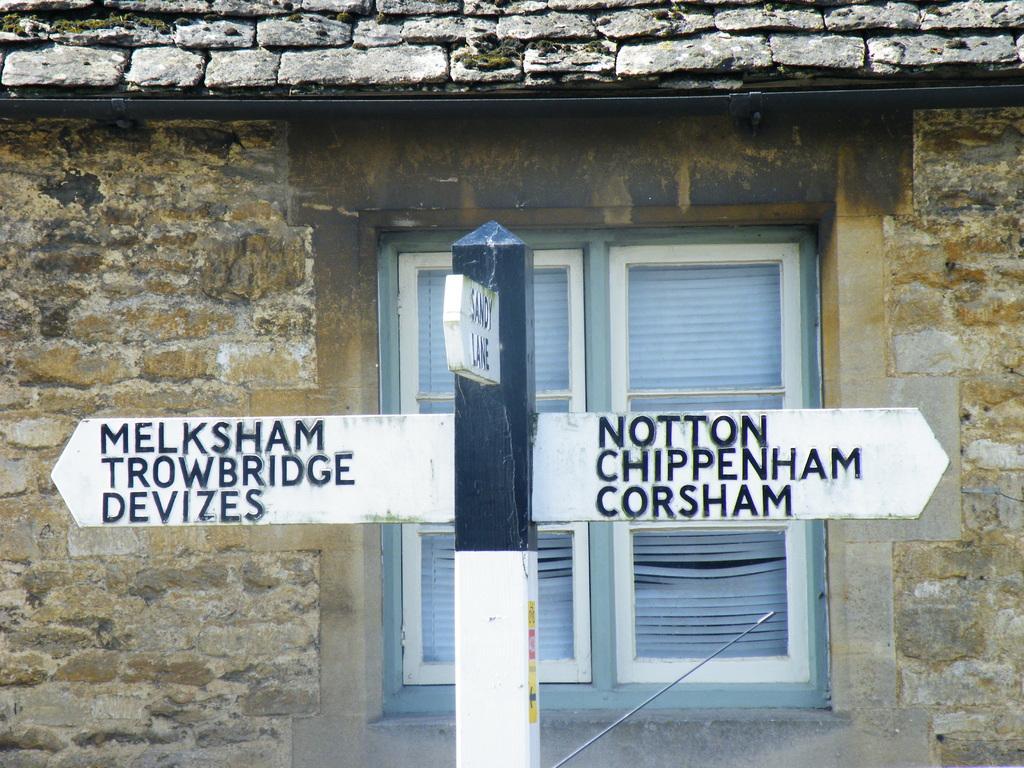Please provide a concise description of this image. At the center of the image there is a directional sign board attached to the pole, behind the pole there is a house with bricks and a window. 